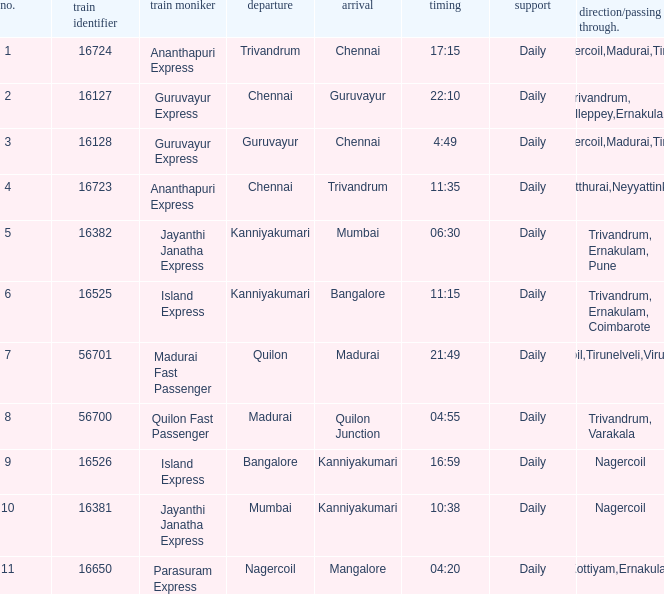I'm looking to parse the entire table for insights. Could you assist me with that? {'header': ['no.', 'train identifier', 'train moniker', 'departure', 'arrival', 'timing', 'support', 'direction/passing through.'], 'rows': [['1', '16724', 'Ananthapuri Express', 'Trivandrum', 'Chennai', '17:15', 'Daily', 'Nagercoil,Madurai,Tiruchi'], ['2', '16127', 'Guruvayur Express', 'Chennai', 'Guruvayur', '22:10', 'Daily', 'Trivandrum, Alleppey,Ernakulam'], ['3', '16128', 'Guruvayur Express', 'Guruvayur', 'Chennai', '4:49', 'Daily', 'Nagercoil,Madurai,Tiruchi'], ['4', '16723', 'Ananthapuri Express', 'Chennai', 'Trivandrum', '11:35', 'Daily', 'Kulitthurai,Neyyattinkara'], ['5', '16382', 'Jayanthi Janatha Express', 'Kanniyakumari', 'Mumbai', '06:30', 'Daily', 'Trivandrum, Ernakulam, Pune'], ['6', '16525', 'Island Express', 'Kanniyakumari', 'Bangalore', '11:15', 'Daily', 'Trivandrum, Ernakulam, Coimbarote'], ['7', '56701', 'Madurai Fast Passenger', 'Quilon', 'Madurai', '21:49', 'Daily', 'Nagercoil,Tirunelveli,Virudunagar'], ['8', '56700', 'Quilon Fast Passenger', 'Madurai', 'Quilon Junction', '04:55', 'Daily', 'Trivandrum, Varakala'], ['9', '16526', 'Island Express', 'Bangalore', 'Kanniyakumari', '16:59', 'Daily', 'Nagercoil'], ['10', '16381', 'Jayanthi Janatha Express', 'Mumbai', 'Kanniyakumari', '10:38', 'Daily', 'Nagercoil'], ['11', '16650', 'Parasuram Express', 'Nagercoil', 'Mangalore', '04:20', 'Daily', 'Trivandrum,Kottiyam,Ernakulam,Kozhikode']]} What is the origin when the destination is Mumbai? Kanniyakumari. 